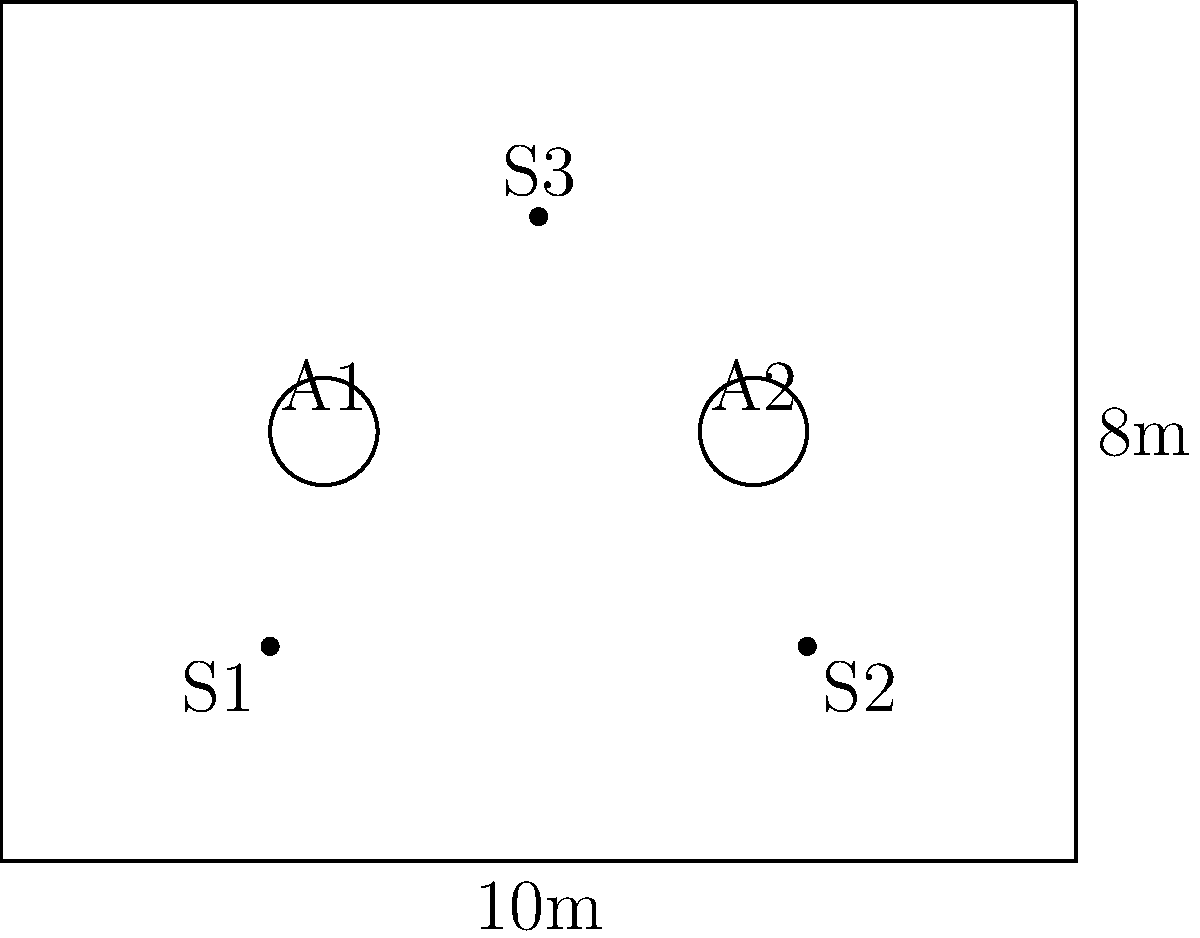In a rectangular museum gallery measuring 10m by 8m, two artworks (A1 and A2) are placed as shown in the diagram. Three speakers (S1, S2, and S3) need to be positioned to create an immersive audio experience. If the ideal speaker placement requires that the sum of the distances from each artwork to its nearest speaker is minimized, what is the optimal y-coordinate for speakers S1 and S2? To find the optimal y-coordinate for speakers S1 and S2, we need to minimize the sum of distances from each artwork to its nearest speaker. Let's approach this step-by-step:

1) Given the x-coordinates:
   S1: x = 2.5m
   S2: x = 7.5m
   A1: x = 3m
   A2: x = 7m

2) Let y be the unknown y-coordinate for S1 and S2.

3) The distance from A1 to S1 can be expressed as:
   $d_1 = \sqrt{(3-2.5)^2 + (4-y)^2} = \sqrt{0.25 + (4-y)^2}$

4) The distance from A2 to S2 can be expressed as:
   $d_2 = \sqrt{(7-7.5)^2 + (4-y)^2} = \sqrt{0.25 + (4-y)^2}$

5) We need to minimize $d_1 + d_2$. Since both distances have the same form, we can simplify our problem to minimizing:
   $f(y) = 2\sqrt{0.25 + (4-y)^2}$

6) To find the minimum, we differentiate $f(y)$ and set it to zero:
   $f'(y) = 2 \cdot \frac{1}{2\sqrt{0.25 + (4-y)^2}} \cdot 2(4-y)(-1) = 0$

7) Solving this equation:
   $\frac{-(4-y)}{\sqrt{0.25 + (4-y)^2}} = 0$
   $4-y = 0$
   $y = 4$

8) The second derivative is positive at y = 4, confirming this is a minimum.

Therefore, the optimal y-coordinate for speakers S1 and S2 is 4m, which is the same y-coordinate as the artworks.
Answer: 4m 